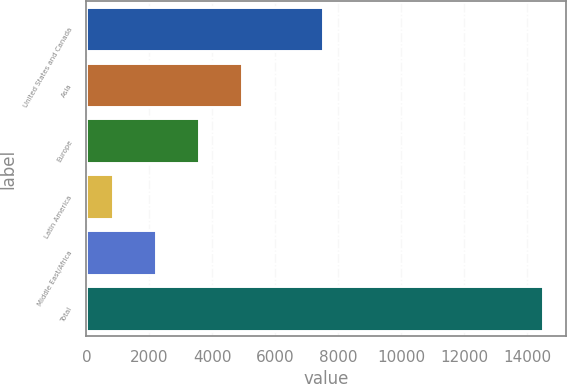Convert chart to OTSL. <chart><loc_0><loc_0><loc_500><loc_500><bar_chart><fcel>United States and Canada<fcel>Asia<fcel>Europe<fcel>Latin America<fcel>Middle East/Africa<fcel>Total<nl><fcel>7505<fcel>4940.4<fcel>3571.6<fcel>834<fcel>2202.8<fcel>14522<nl></chart> 